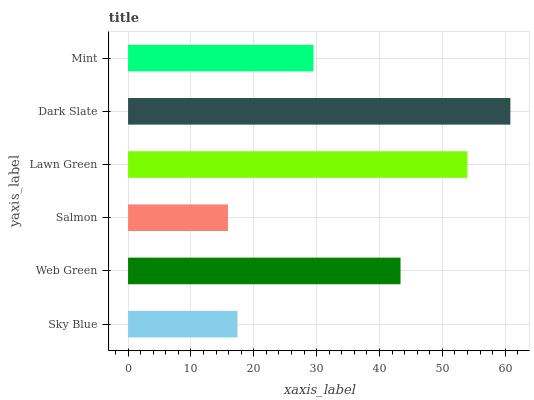Is Salmon the minimum?
Answer yes or no. Yes. Is Dark Slate the maximum?
Answer yes or no. Yes. Is Web Green the minimum?
Answer yes or no. No. Is Web Green the maximum?
Answer yes or no. No. Is Web Green greater than Sky Blue?
Answer yes or no. Yes. Is Sky Blue less than Web Green?
Answer yes or no. Yes. Is Sky Blue greater than Web Green?
Answer yes or no. No. Is Web Green less than Sky Blue?
Answer yes or no. No. Is Web Green the high median?
Answer yes or no. Yes. Is Mint the low median?
Answer yes or no. Yes. Is Lawn Green the high median?
Answer yes or no. No. Is Web Green the low median?
Answer yes or no. No. 